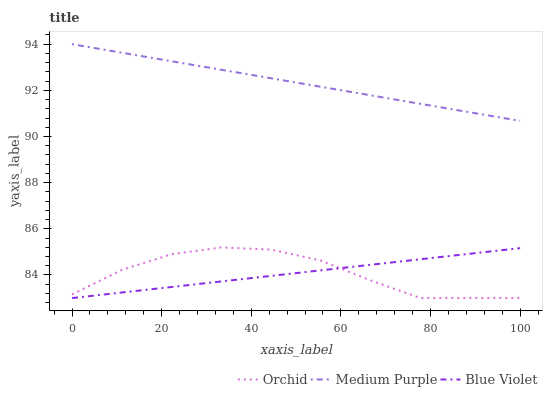Does Blue Violet have the minimum area under the curve?
Answer yes or no. Yes. Does Medium Purple have the maximum area under the curve?
Answer yes or no. Yes. Does Orchid have the minimum area under the curve?
Answer yes or no. No. Does Orchid have the maximum area under the curve?
Answer yes or no. No. Is Medium Purple the smoothest?
Answer yes or no. Yes. Is Orchid the roughest?
Answer yes or no. Yes. Is Blue Violet the smoothest?
Answer yes or no. No. Is Blue Violet the roughest?
Answer yes or no. No. Does Blue Violet have the lowest value?
Answer yes or no. Yes. Does Medium Purple have the highest value?
Answer yes or no. Yes. Does Orchid have the highest value?
Answer yes or no. No. Is Blue Violet less than Medium Purple?
Answer yes or no. Yes. Is Medium Purple greater than Orchid?
Answer yes or no. Yes. Does Orchid intersect Blue Violet?
Answer yes or no. Yes. Is Orchid less than Blue Violet?
Answer yes or no. No. Is Orchid greater than Blue Violet?
Answer yes or no. No. Does Blue Violet intersect Medium Purple?
Answer yes or no. No. 